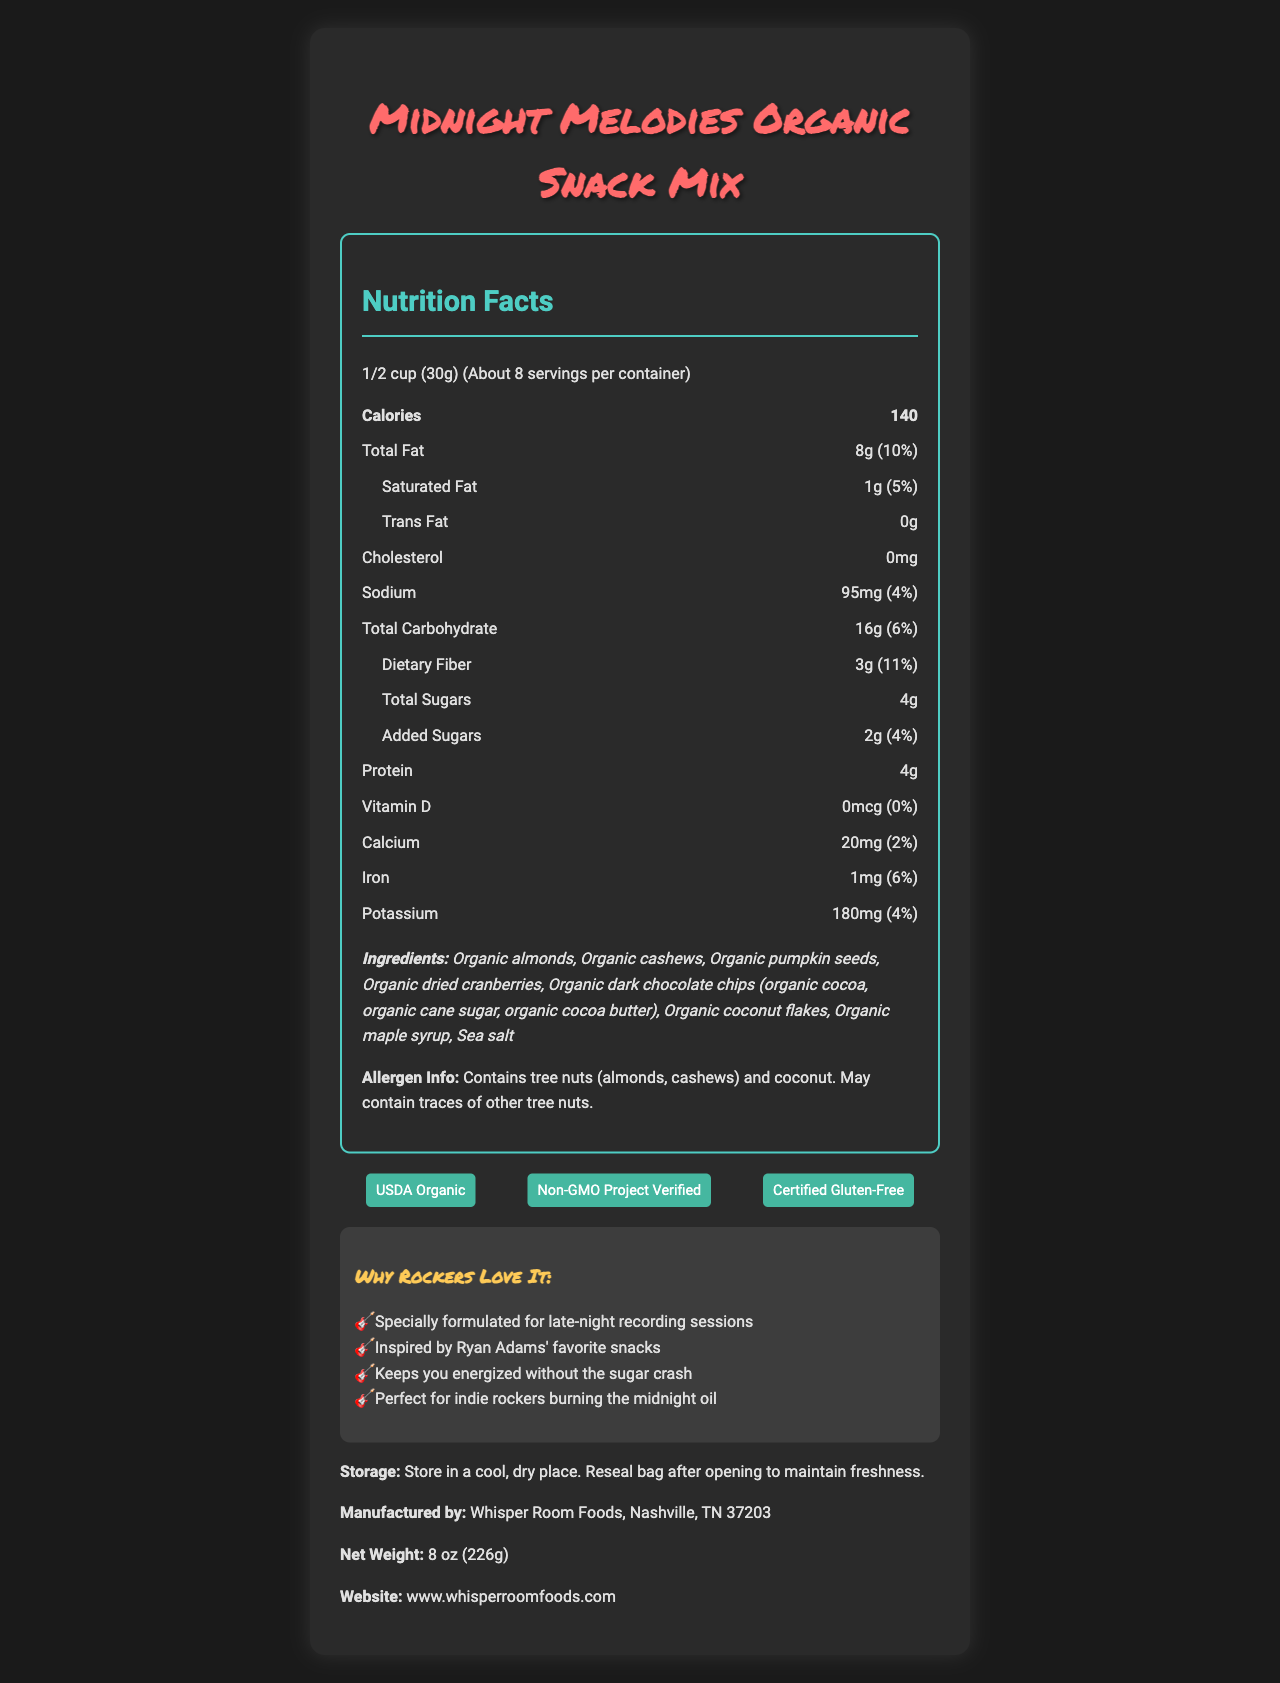what is the serving size? The serving size is clearly mentioned at the top of the Nutrition Facts section as "1/2 cup (30g)".
Answer: 1/2 cup (30g) how many calories are in one serving? The Nutrition Facts label lists 140 calories per serving.
Answer: 140 what is the total fat content per serving? The document specifies that there are 8 grams of total fat per serving.
Answer: 8g how much dietary fiber is in each serving? The dietary fiber content per serving is listed as 3 grams on the Nutrition Facts label.
Answer: 3g what is the amount of added sugars per serving? The amount of added sugars per serving is noted as 2 grams in the Nutrition Facts.
Answer: 2g how many servings are in the container? A. About 5 B. About 6 C. About 8 D. About 10 According to the Nutrition Facts, there are "About 8" servings per container.
Answer: C what certifications does this product have? A. USDA Organic B. Non-GMO Project Verified C. Certified Gluten-Free D. All of the above The document lists the certifications as "USDA Organic," "Non-GMO Project Verified," and "Certified Gluten-Free."
Answer: D is the snack mix gluten-free? The product has a "Certified Gluten-Free" certification, as mentioned in the document.
Answer: Yes describe the main idea of the document. The document offers a comprehensive description of the snack mix, including its nutritional values, ingredient list, allergen info, certifications, and marketing claims directed towards indie rock enthusiasts.
Answer: The document provides detailed nutritional information, ingredients, certifications, and marketing claims for "Midnight Melodies Organic Snack Mix." It highlights the product's organic, gluten-free nature and its suitability for late-night recording sessions, drawing inspiration from Ryan Adams' favorite snacks. are there any artificial ingredients in this snack mix? The ingredients listed are all organic, including almonds, cashews, pumpkin seeds, dried cranberries, dark chocolate chips, coconut flakes, maple syrup, and sea salt, indicating that there are no artificial ingredients.
Answer: No who is the product specifically formulated for? The marketing claims mention that the snack mix is "Specially formulated for late-night recording sessions."
Answer: Late-night recording sessions what is the name of the company that manufactures this snack mix? The document states that the product is manufactured by "Whisper Room Foods, Nashville, TN 37203."
Answer: Whisper Room Foods what is the net weight of the product? The net weight is clearly mentioned as "8 oz (226g)."
Answer: 8 oz (226g) how much iron is in one serving? The Nutrition Facts label lists 1mg of iron per serving.
Answer: 1mg how many grams of protein are in each serving? The document specifies that there are 4 grams of protein per serving.
Answer: 4g does this product contain dairy? The ingredient list does not mention any dairy, but the allergen information only lists tree nuts and coconut. Without further information, it is not possible to determine if the product contains any dairy.
Answer: Cannot be determined 